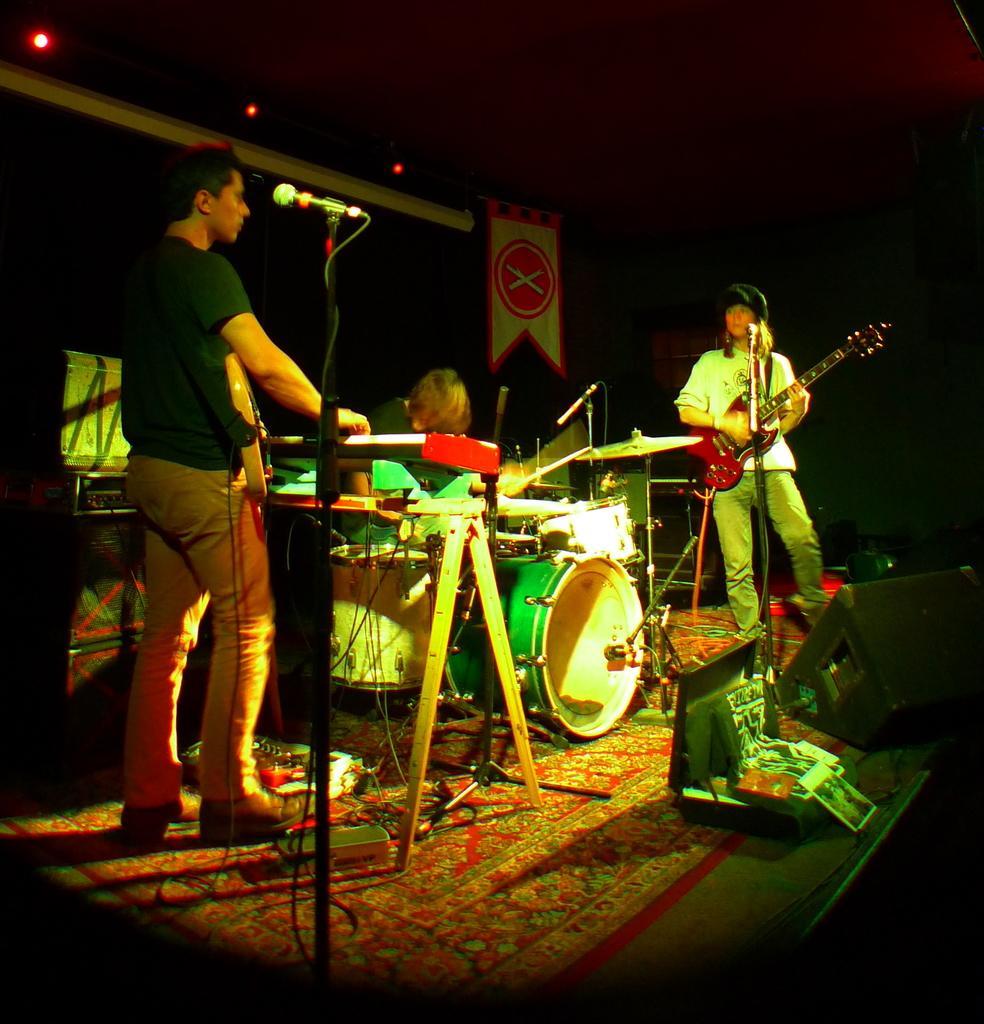Describe this image in one or two sentences. In this picture we can see three people playing musical in instruments such as guitar, piano, drums and in front of them there are mics and in the background we can see banners, light. 